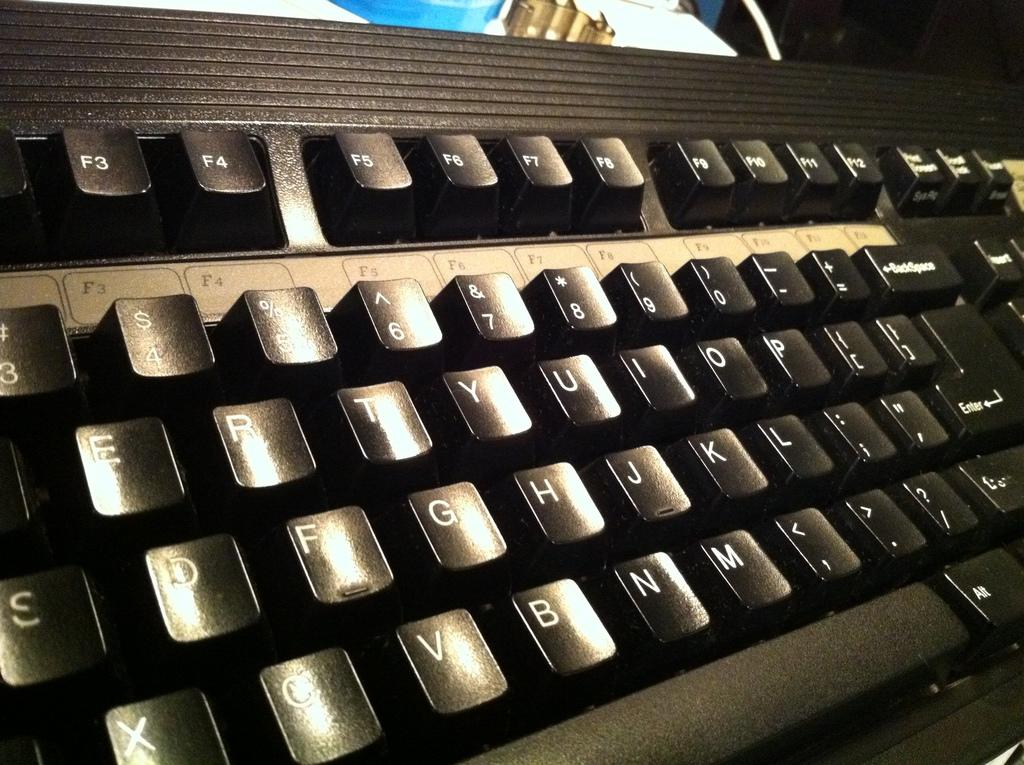What is the main object in the image? There is a keyboard in the image. Can you describe the keyboard in more detail? The keyboard appears to have keys and may be used for typing or playing music. Is there anything else in the image besides the keyboard? The provided facts do not mention any other objects in the image. How many gravestones can be seen in the image? There are no gravestones present in the image, as it features a keyboard. 